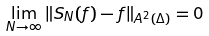<formula> <loc_0><loc_0><loc_500><loc_500>\lim _ { N \rightarrow \infty } \| S _ { N } ( f ) - f \| _ { A ^ { 2 } ( \Delta ) } = 0</formula> 